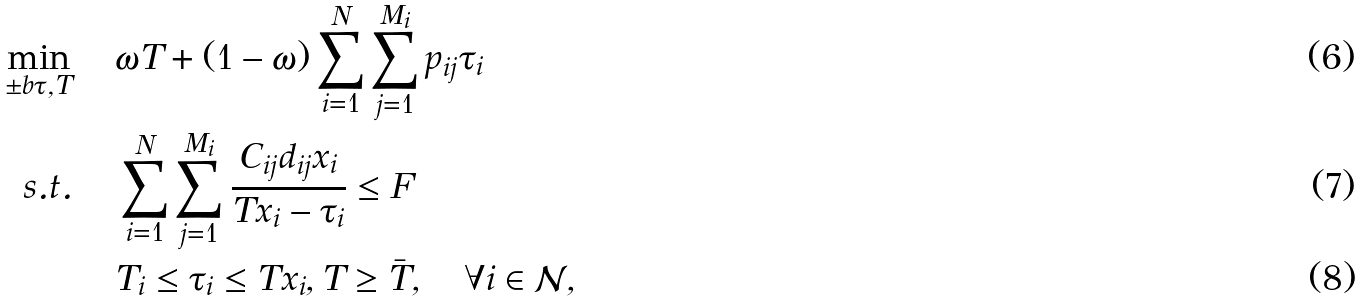Convert formula to latex. <formula><loc_0><loc_0><loc_500><loc_500>\min _ { \pm b \tau , T } \, \quad & \omega T + ( 1 - \omega ) \sum _ { i = 1 } ^ { N } \sum _ { j = 1 } ^ { M _ { i } } p _ { i j } \tau _ { i } \\ s . t . \quad \, & \sum _ { i = 1 } ^ { N } \sum _ { j = 1 } ^ { M _ { i } } \frac { C _ { i j } d _ { i j } x _ { i } } { T x _ { i } - \tau _ { i } } \leq F \\ & T _ { i } \leq \tau _ { i } \leq T x _ { i } , T \geq \bar { T } , \quad \forall i \in \mathcal { N } ,</formula> 